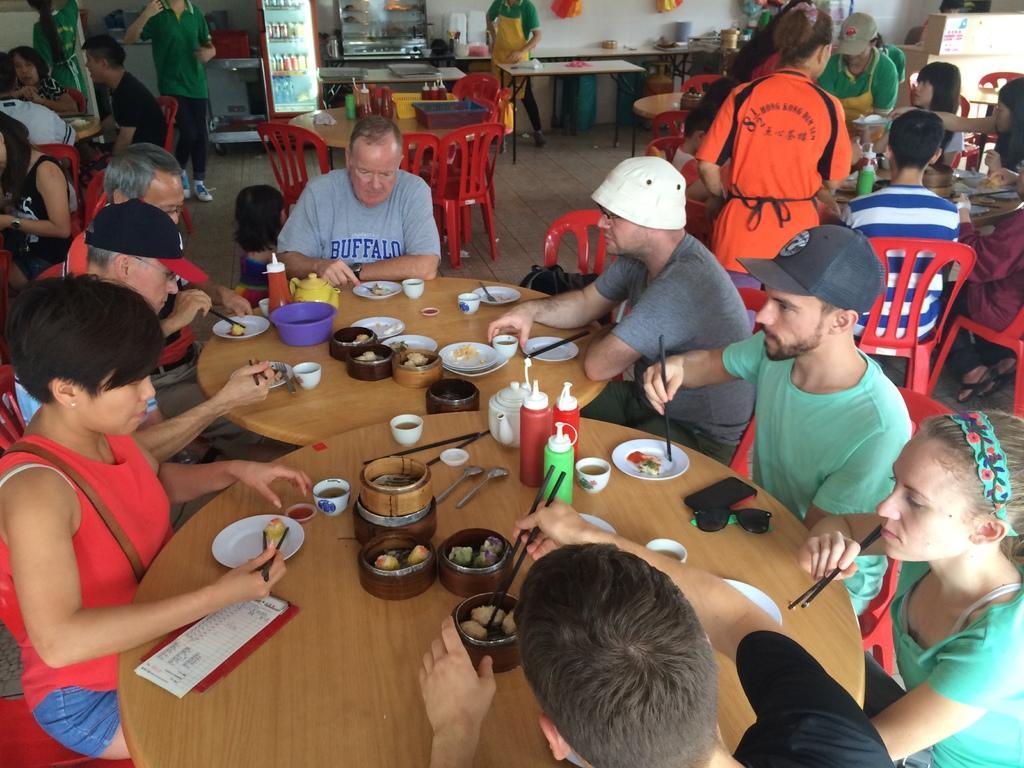How would you summarize this image in a sentence or two? This picture is clicked inside the room and we can see the group of persons sitting on the red color chairs and we can see the wooden tables on the top of which bottles, spoons, chopsticks, platters, cups and food items and many other items are placed and we can see the group of persons standing on the ground. In the background we can see the wall and there are some objects hanging on the wall and we can see a box and many other objects. 